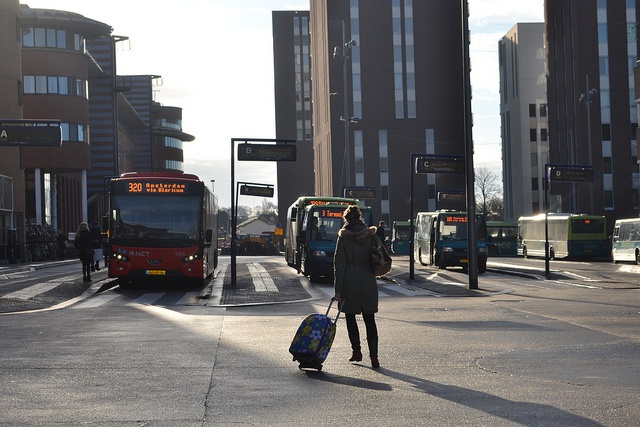Describe the objects in this image and their specific colors. I can see bus in gray, black, navy, and maroon tones, people in gray, black, darkgray, and tan tones, bus in gray, black, and darkgray tones, bus in gray, black, navy, and darkblue tones, and bus in gray, black, darkgray, and ivory tones in this image. 